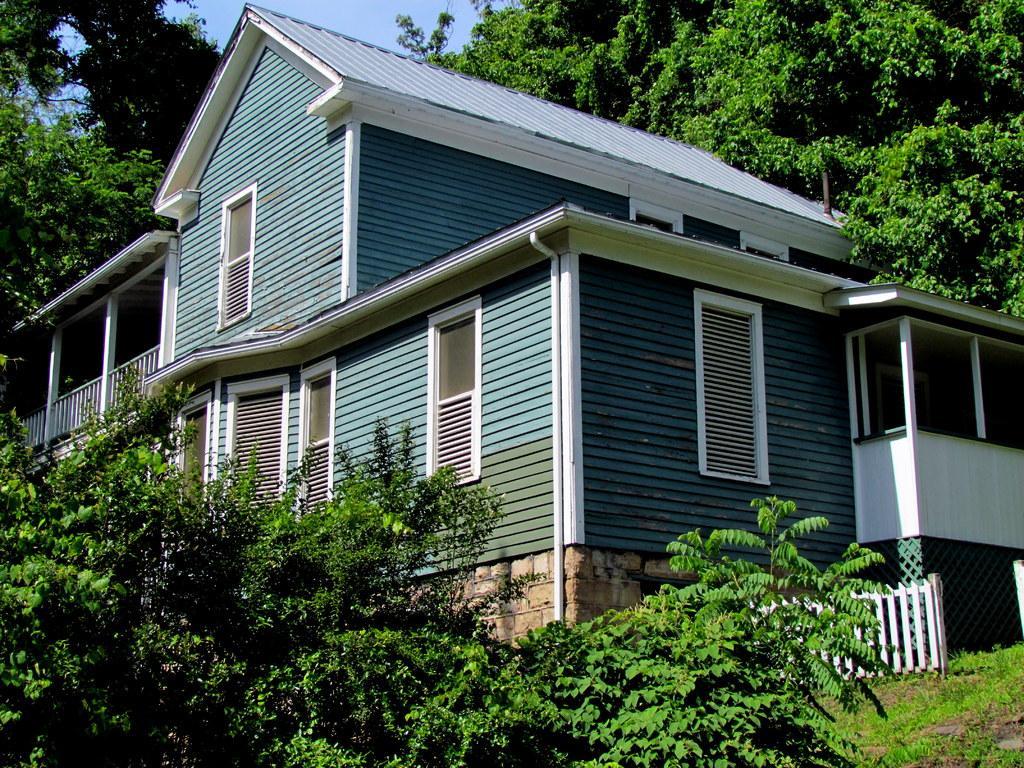Describe this image in one or two sentences. In this image we can see plants, wooden fence, stone wall, wooden house, trees and the sky in the background. 